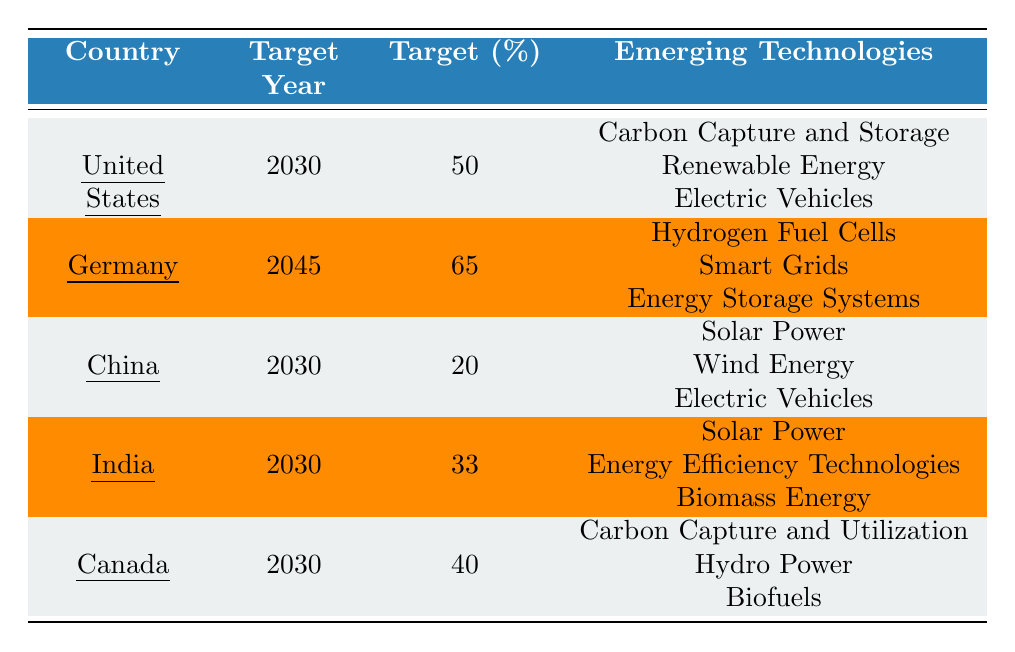What is the carbon emission reduction target percentage for the United States? The table shows that the United States has a target percentage of 50% for carbon emission reduction.
Answer: 50% Which country has the highest carbon emission reduction target percentage? According to the table, Germany has the highest target percentage of 65%.
Answer: Germany How many countries have a target year of 2030? The table lists the United States, China, India, and Canada, totaling four countries that have a target year of 2030.
Answer: 4 Is India targeting a higher percentage reduction than China? India has a target percentage of 33%, while China targets 20%, which means India has a higher target.
Answer: Yes What is the difference in target percentages between Germany and Canada? Germany's target is 65% while Canada's is 40%, so the difference is 65 - 40 = 25%.
Answer: 25% List the emerging technologies for Canada. The table indicates that the emerging technologies for Canada include Carbon Capture and Utilization, Hydro Power, and Biofuels.
Answer: Carbon Capture and Utilization, Hydro Power, Biofuels Which emerging technology appears in both the United States and China? Electric Vehicles is listed as an emerging technology for both the United States and China according to the table.
Answer: Electric Vehicles What is the average target percentage for countries targeting by 2030? The countries targeting by 2030 are the United States (50%), China (20%), India (33%), and Canada (40%). The sum is 50 + 20 + 33 + 40 = 143, and the average is 143/4 = 35.75%.
Answer: 35.75% Does any country have a target year beyond 2045? The table shows that Germany's target year is 2045 and no other listed country has a later year; thus, the answer is no.
Answer: No Which technologies is Germany focusing on for carbon emission reduction? The technologies mentioned for Germany include Hydrogen Fuel Cells, Smart Grids, and Energy Storage Systems.
Answer: Hydrogen Fuel Cells, Smart Grids, Energy Storage Systems 